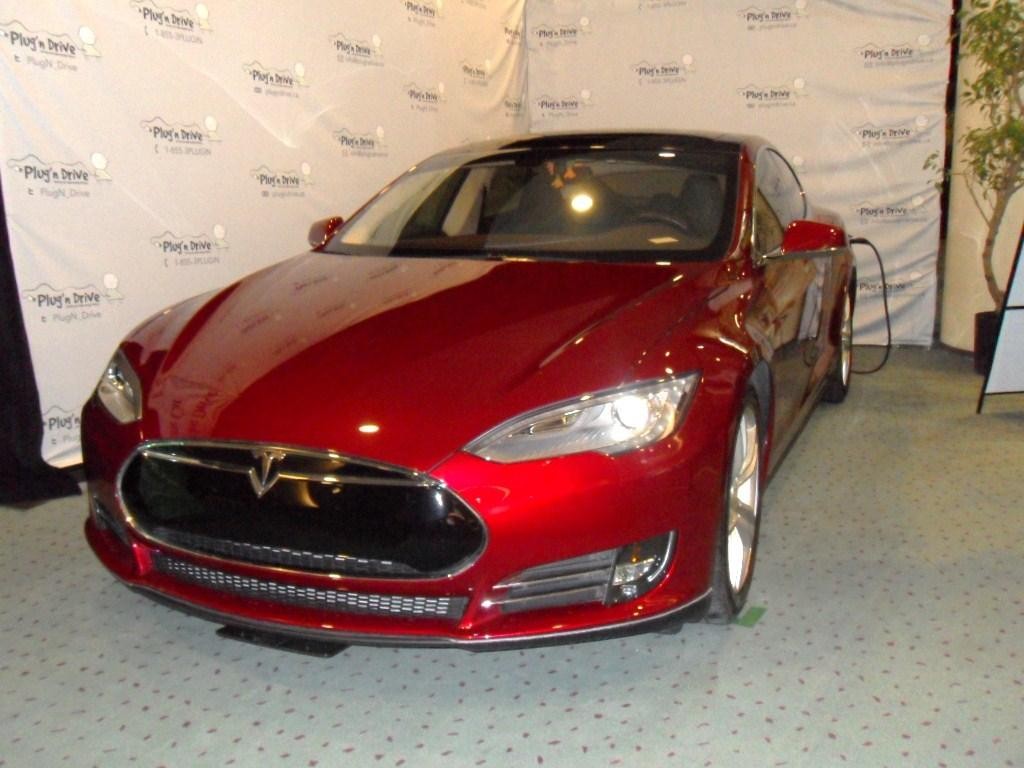What object is placed on the floor in the image? There is a car on the floor in the image. What can be seen in the background of the image? There are banners in the background of the image. What is located on the right side of the image? There is a board and a pillar on the right side of the image. What type of vegetation is present in the image? There is a plant in a flower pot on the right side of the image. How many kittens are playing on the slope in the image? There are no kittens or slopes present in the image. What type of currency is visible in the image? There is no currency visible in the image. 